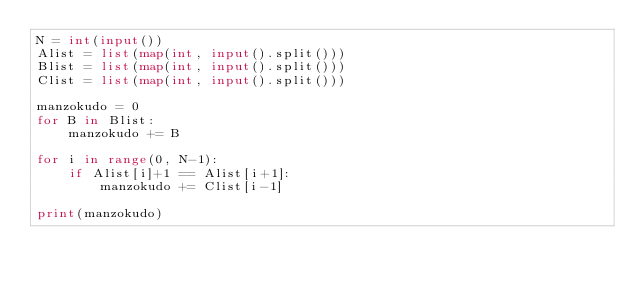Convert code to text. <code><loc_0><loc_0><loc_500><loc_500><_Python_>N = int(input())
Alist = list(map(int, input().split()))
Blist = list(map(int, input().split()))
Clist = list(map(int, input().split()))

manzokudo = 0
for B in Blist:
    manzokudo += B
    
for i in range(0, N-1):
    if Alist[i]+1 == Alist[i+1]:
        manzokudo += Clist[i-1]

print(manzokudo)</code> 